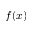<formula> <loc_0><loc_0><loc_500><loc_500>f ( x )</formula> 